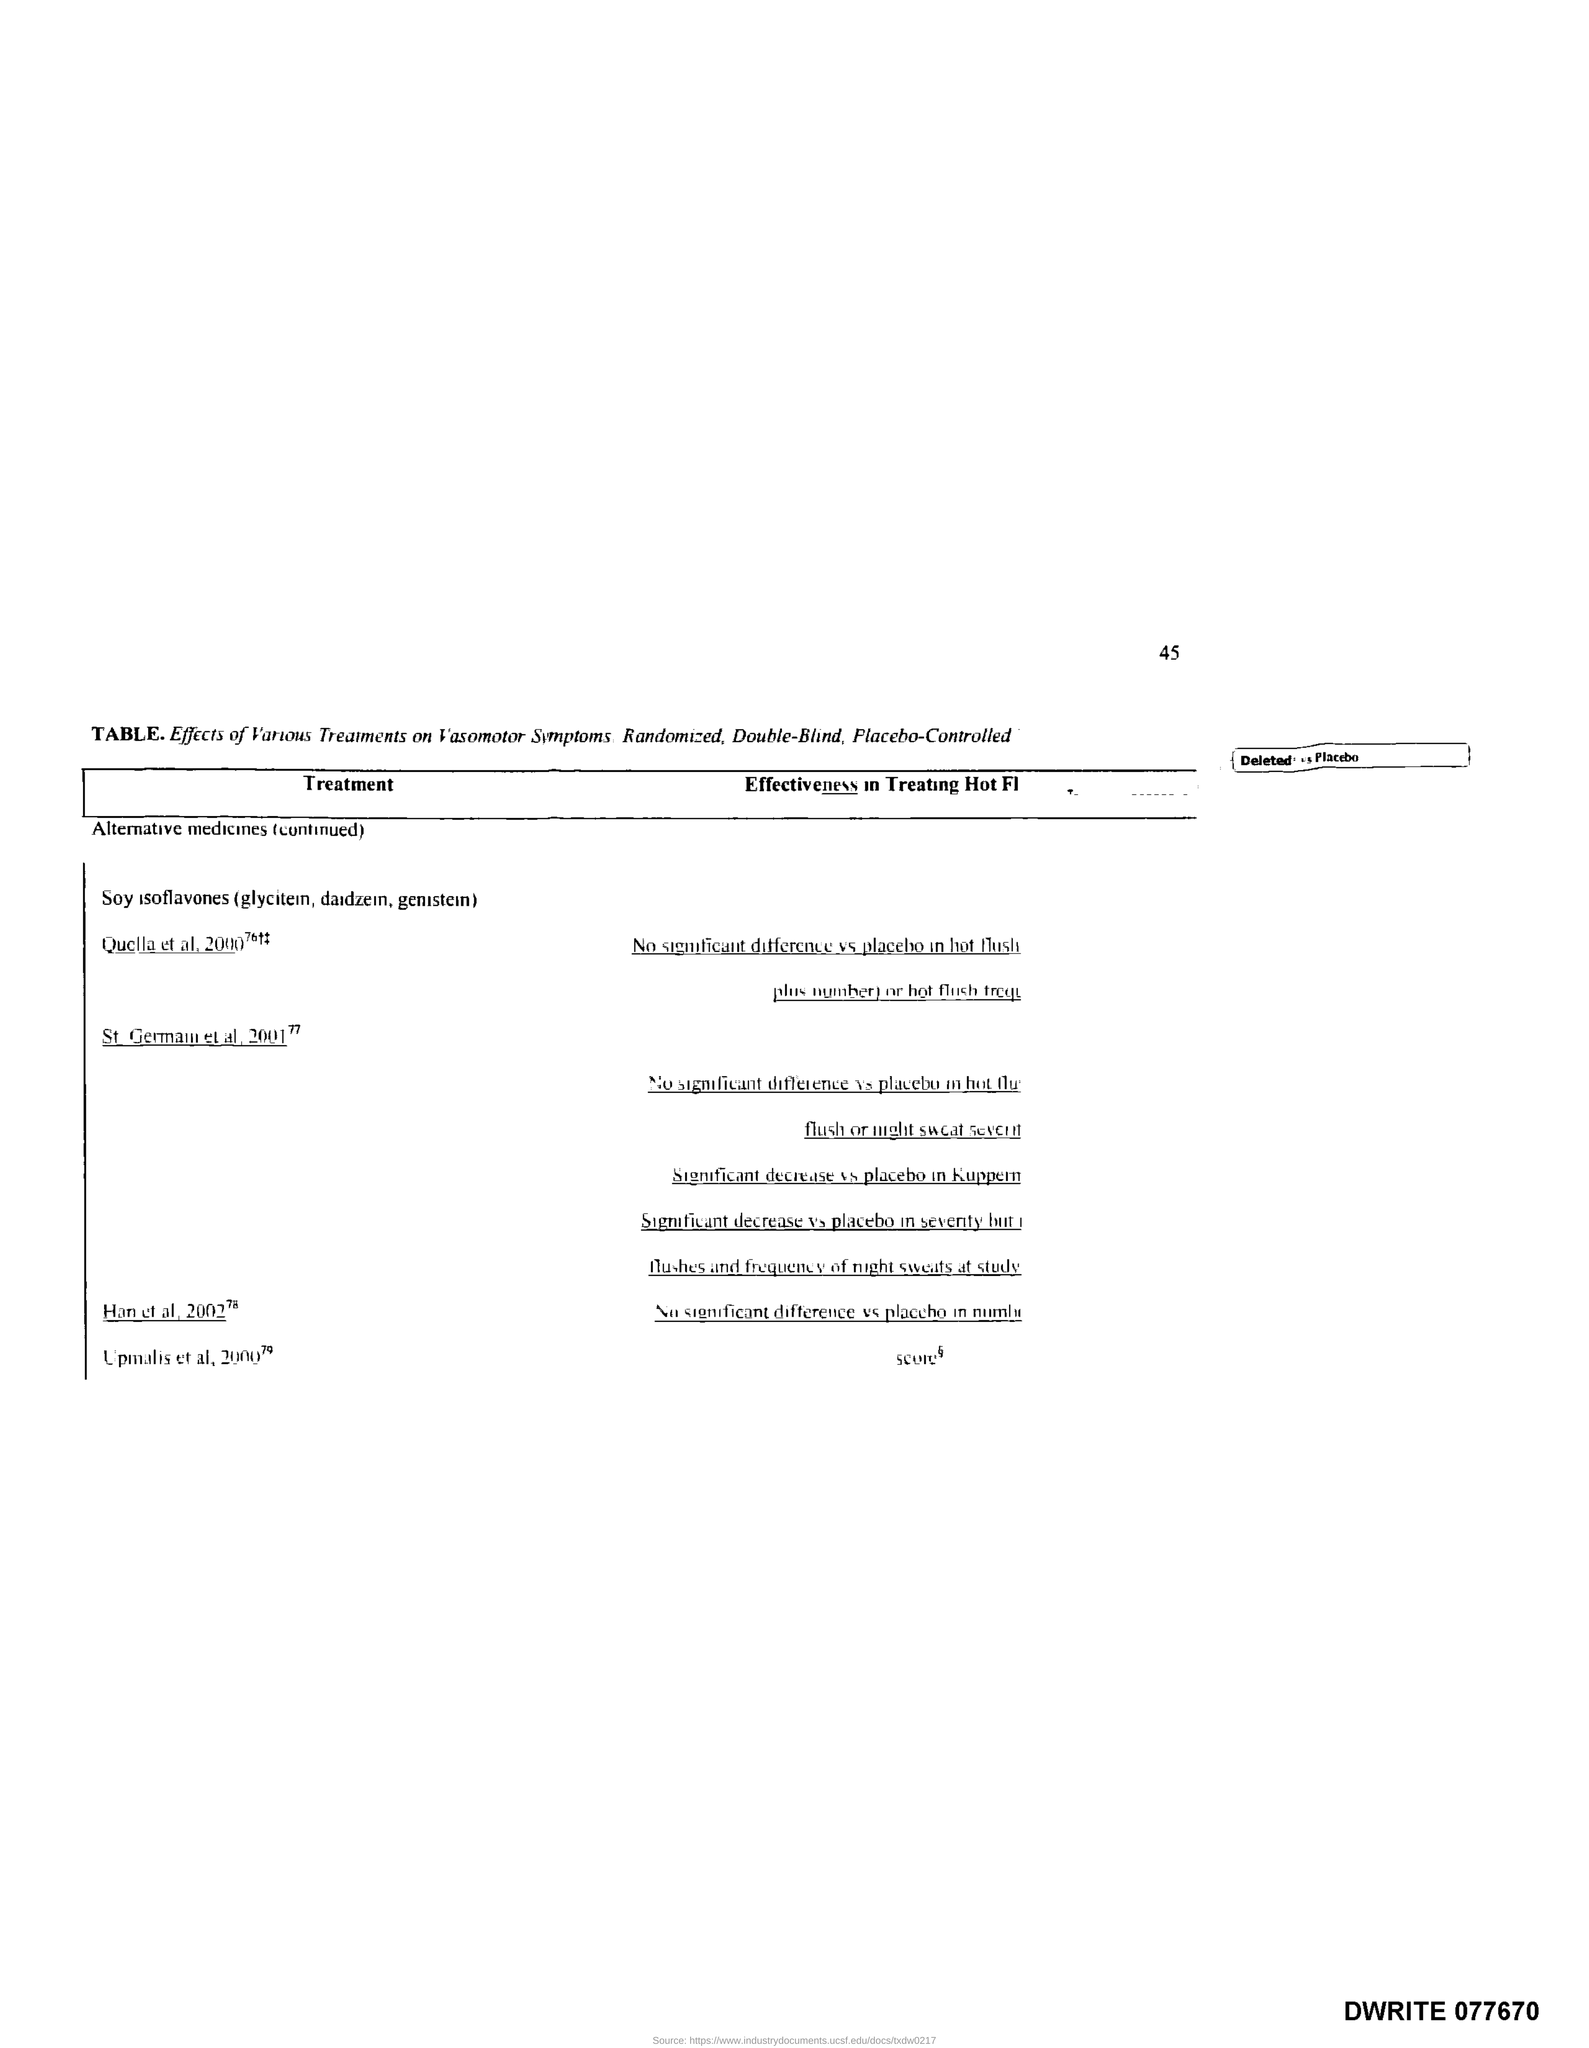What is the page number?
Make the answer very short. 45. What is the title of the first column of the table?
Your response must be concise. Treatment. 